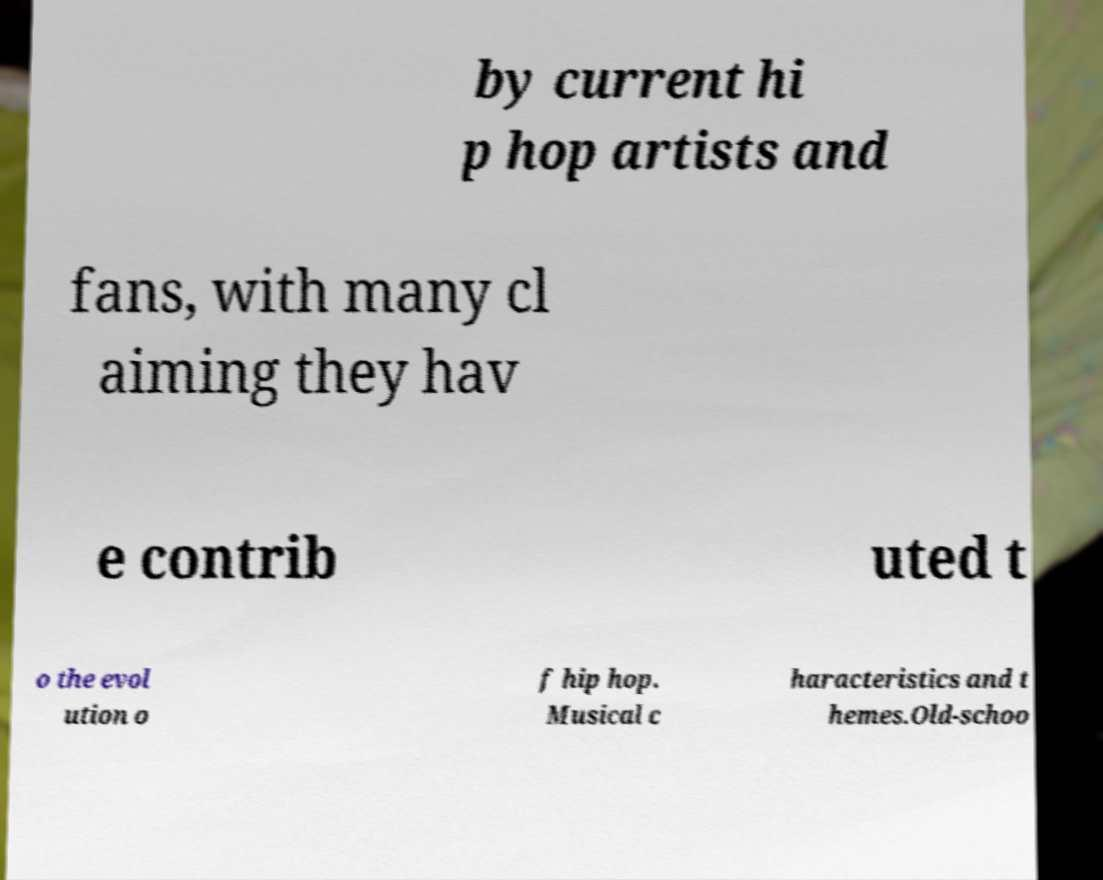Please read and relay the text visible in this image. What does it say? by current hi p hop artists and fans, with many cl aiming they hav e contrib uted t o the evol ution o f hip hop. Musical c haracteristics and t hemes.Old-schoo 